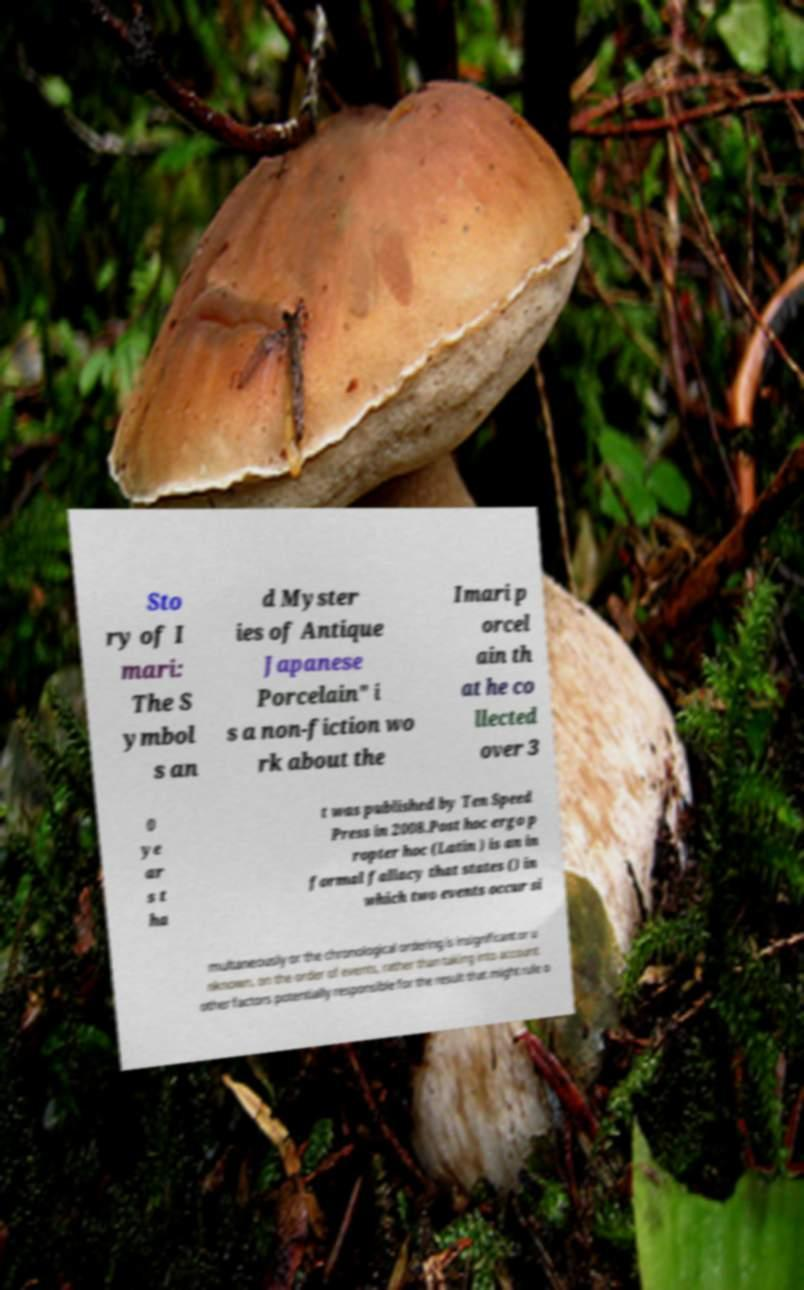Please read and relay the text visible in this image. What does it say? Sto ry of I mari: The S ymbol s an d Myster ies of Antique Japanese Porcelain" i s a non-fiction wo rk about the Imari p orcel ain th at he co llected over 3 0 ye ar s t ha t was published by Ten Speed Press in 2008.Post hoc ergo p ropter hoc (Latin ) is an in formal fallacy that states () in which two events occur si multaneously or the chronological ordering is insignificant or u nknown. on the order of events, rather than taking into account other factors potentially responsible for the result that might rule o 